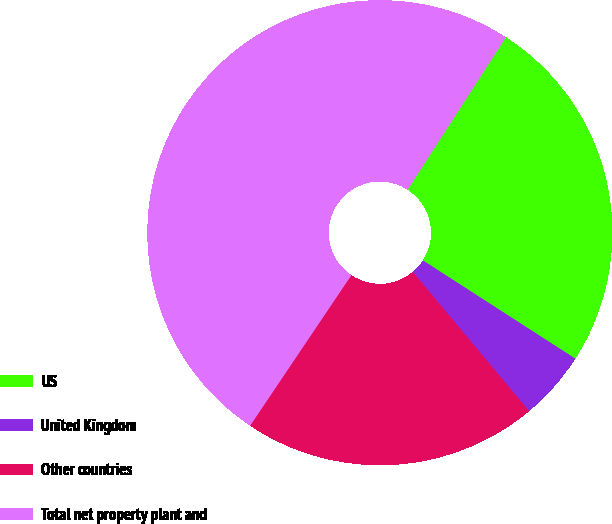<chart> <loc_0><loc_0><loc_500><loc_500><pie_chart><fcel>US<fcel>United Kingdom<fcel>Other countries<fcel>Total net property plant and<nl><fcel>25.0%<fcel>4.8%<fcel>20.51%<fcel>49.69%<nl></chart> 